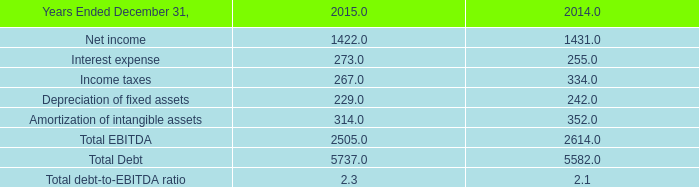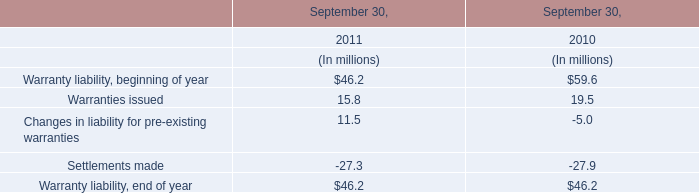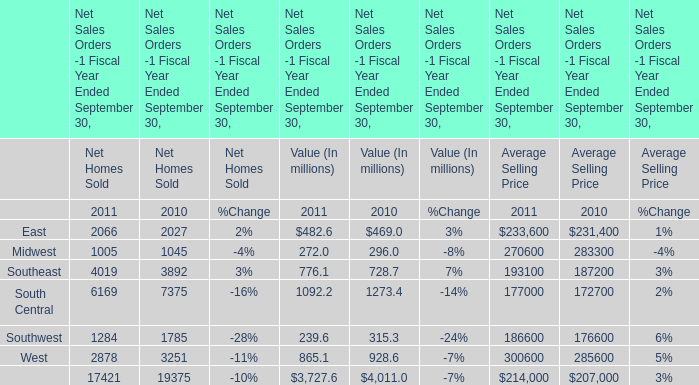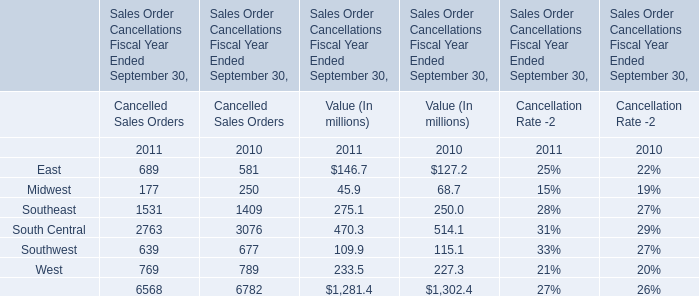What's the current increasing rate of East for Value (In millions)? 
Computations: ((482.6 - 469) / 469)
Answer: 0.029. 